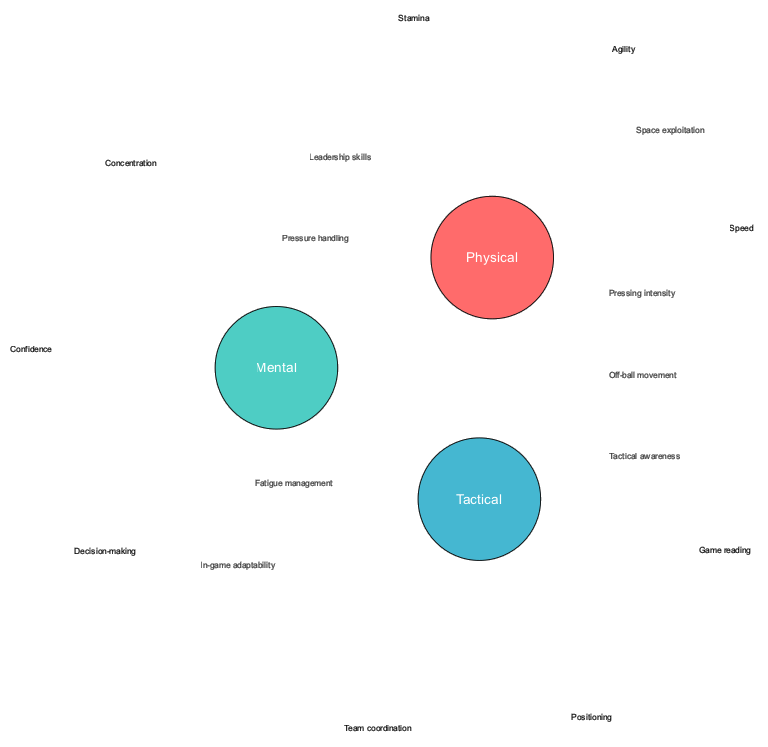What are the three main aspects represented in the circles? The diagram features three main aspects represented by circles: Physical, Mental, and Tactical.
Answer: Physical, Mental, Tactical How many elements are in the Physical circle? The Physical circle contains three elements listed as Stamina, Speed, and Agility, which can be counted directly from the diagram.
Answer: 3 What are the elements that overlap between Physical and Mental? The overlap between the Physical and Mental circles includes Pressure handling and Fatigue management, which are indicated in the section where these two circles intersect.
Answer: Pressure handling, Fatigue management Which element is present in the overlap of all three circles? The overlap among all three circles includes In-game adaptability and Space exploitation, which signifies aspects that require integration of Physical, Mental, and Tactical skills.
Answer: In-game adaptability, Space exploitation What is the relationship between Mental and Tactical aspects based on the diagram? The Mental and Tactical circles share Leadership skills and Tactical awareness, indicating that these competencies require both mental acuity and tactical understanding.
Answer: Leadership skills, Tactical awareness 